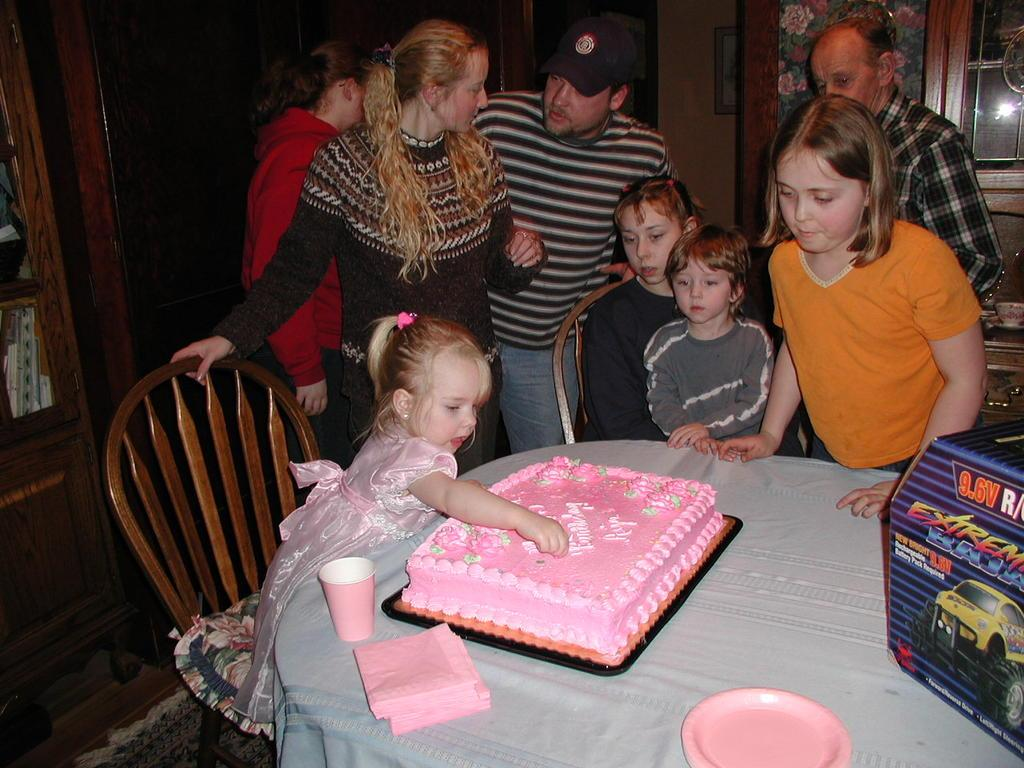What are the people in the image doing? The people in the image are standing. What are the girls in the image doing? The girls in the image are sitting. What is on the table in the image? There is a cake on a table in the image. What type of drum can be seen in the image? There is no drum present in the image. What are the people in the image looking at? The provided facts do not mention what the people are looking at, so we cannot answer this question definitively. 